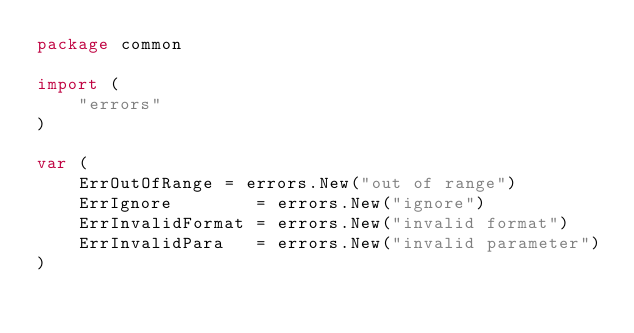<code> <loc_0><loc_0><loc_500><loc_500><_Go_>package common

import (
	"errors"
)

var (
	ErrOutOfRange = errors.New("out of range")
	ErrIgnore        = errors.New("ignore")
	ErrInvalidFormat = errors.New("invalid format")
	ErrInvalidPara   = errors.New("invalid parameter")
)
</code> 